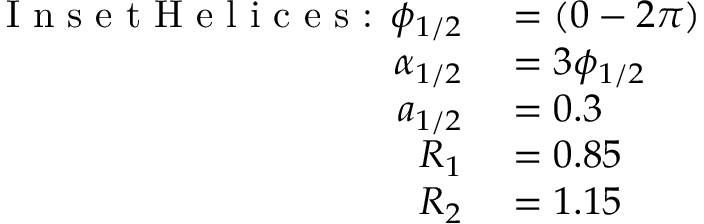Convert formula to latex. <formula><loc_0><loc_0><loc_500><loc_500>\begin{array} { r l } { I n s e t H e l i c e s \colon \phi _ { 1 / 2 } } & = ( 0 - 2 \pi ) } \\ { \alpha _ { 1 / 2 } } & = 3 \phi _ { 1 / 2 } } \\ { a _ { 1 / 2 } } & = 0 . 3 } \\ { R _ { 1 } } & = 0 . 8 5 } \\ { R _ { 2 } } & = 1 . 1 5 } \end{array}</formula> 